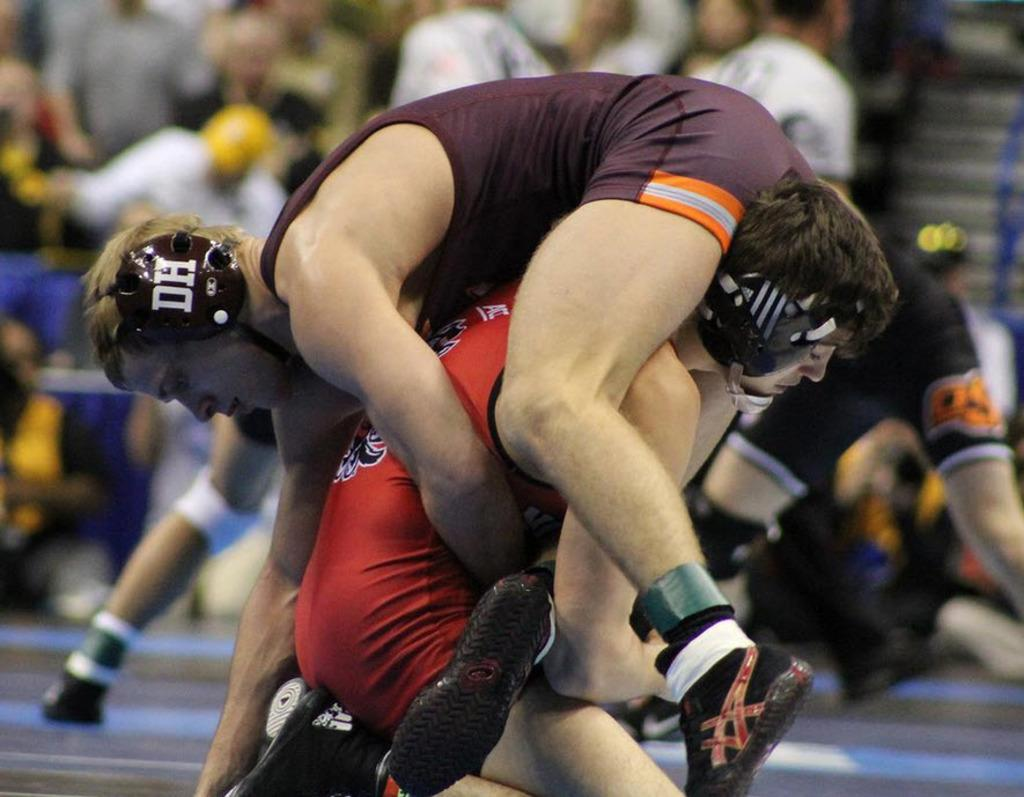<image>
Describe the image concisely. A wrestler with a DH on his ear guard is on top of his opponent. 